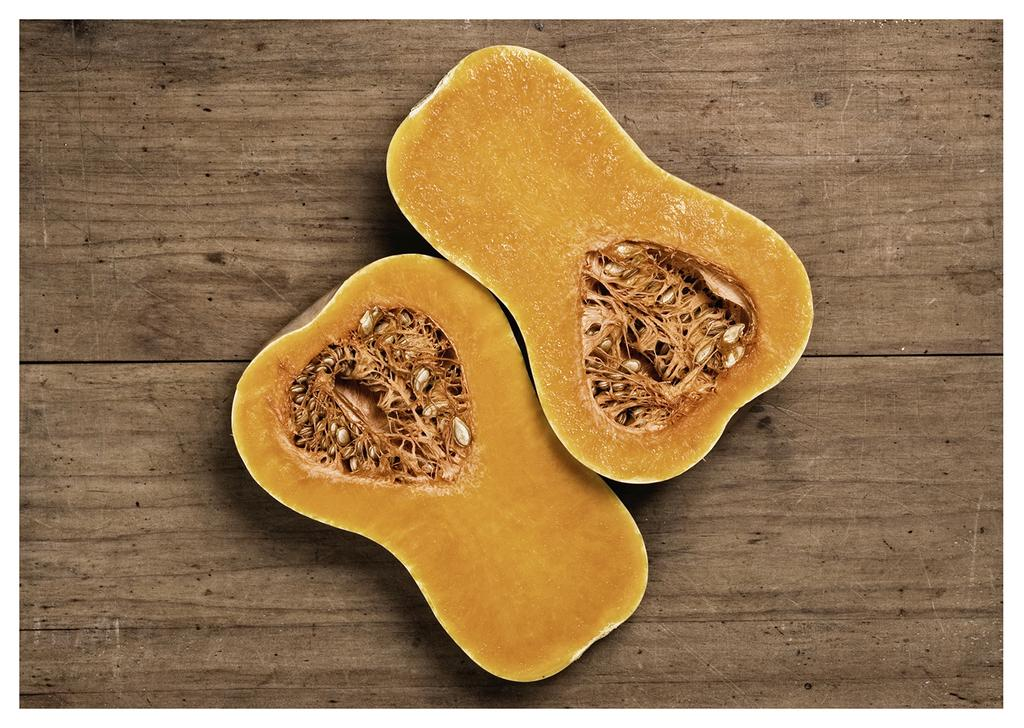What type of vegetable is in the image? There is a Butternut squash in the image. What is the Butternut squash resting on in the image? The Butternut squash is on a wooden surface. What type of pest can be seen crawling on the Butternut squash in the image? There are no pests visible on the Butternut squash in the image. 